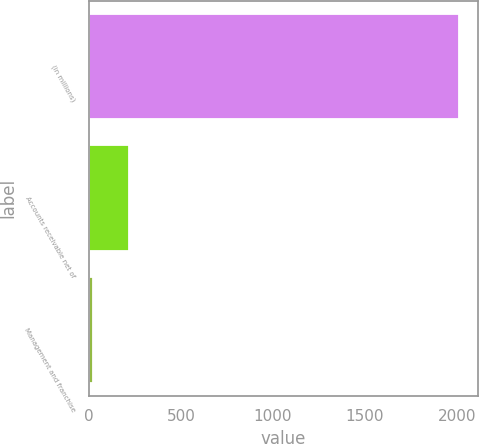Convert chart. <chart><loc_0><loc_0><loc_500><loc_500><bar_chart><fcel>(in millions)<fcel>Accounts receivable net of<fcel>Management and franchise<nl><fcel>2013<fcel>217.5<fcel>18<nl></chart> 